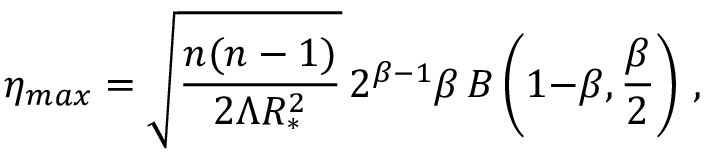Convert formula to latex. <formula><loc_0><loc_0><loc_500><loc_500>\eta _ { \max } = \sqrt { \frac { n ( n - 1 ) } { 2 \Lambda R _ { * } ^ { 2 } } } \, 2 ^ { \beta { - } 1 } \beta \, B \left ( 1 { - } \beta , { \frac { \beta } { 2 } } \right ) \, ,</formula> 